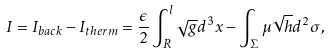<formula> <loc_0><loc_0><loc_500><loc_500>I = I _ { b a c k } - I _ { t h e r m } = \frac { \epsilon } { 2 } \int ^ { l } _ { R } \sqrt { g } d ^ { 3 } x - \int _ { \Sigma } \mu \sqrt { h } d ^ { 2 } \sigma ,</formula> 